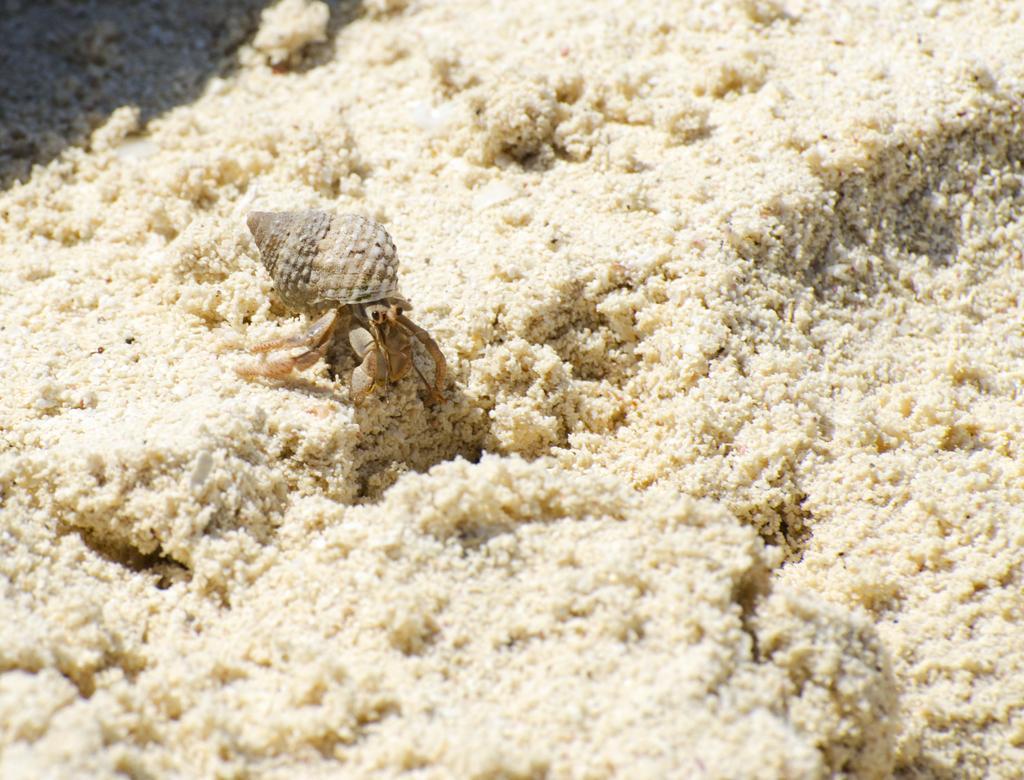How would you summarize this image in a sentence or two? Here in this picture we can see a hermit crab present on the ground over there. 